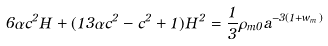<formula> <loc_0><loc_0><loc_500><loc_500>6 \alpha c ^ { 2 } \dot { H } + ( 1 3 \alpha c ^ { 2 } - c ^ { 2 } + 1 ) H ^ { 2 } = \frac { 1 } { 3 } \rho _ { m 0 } a ^ { - 3 ( 1 + w _ { m } ) }</formula> 